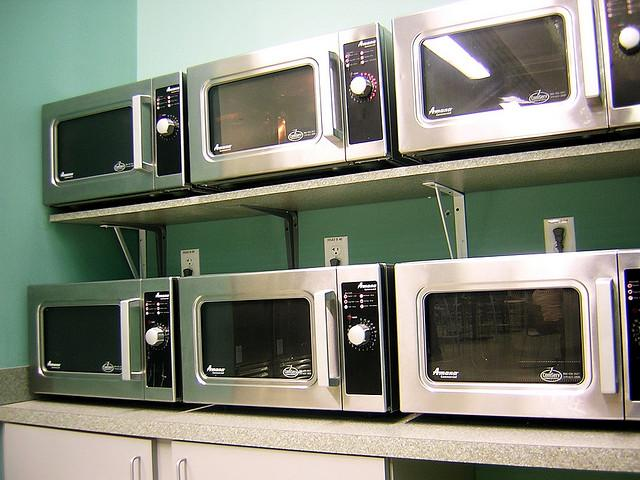Why are there so many microwaves? Please explain your reasoning. for sale. The microwaves are lined up and plugged in for trial. 